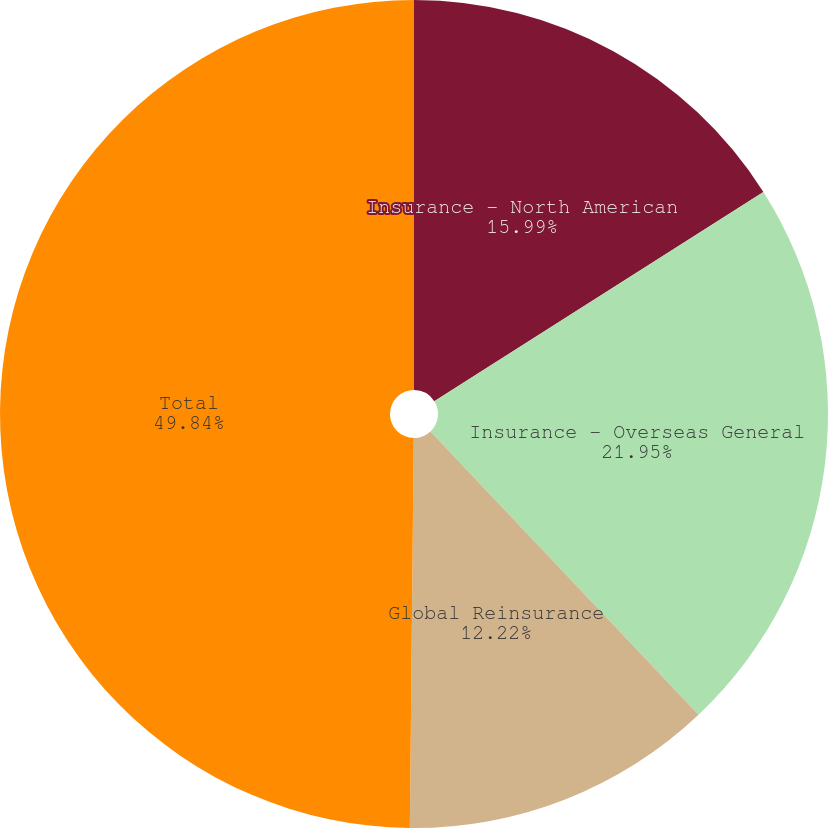Convert chart. <chart><loc_0><loc_0><loc_500><loc_500><pie_chart><fcel>Insurance - North American<fcel>Insurance - Overseas General<fcel>Global Reinsurance<fcel>Total<nl><fcel>15.99%<fcel>21.95%<fcel>12.22%<fcel>49.84%<nl></chart> 